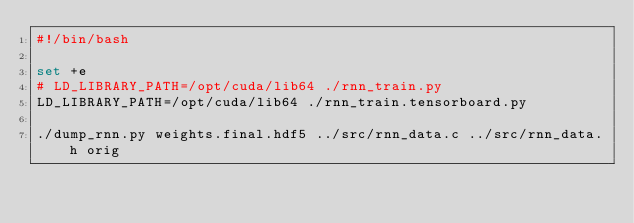<code> <loc_0><loc_0><loc_500><loc_500><_Bash_>#!/bin/bash

set +e
# LD_LIBRARY_PATH=/opt/cuda/lib64 ./rnn_train.py
LD_LIBRARY_PATH=/opt/cuda/lib64 ./rnn_train.tensorboard.py

./dump_rnn.py weights.final.hdf5 ../src/rnn_data.c ../src/rnn_data.h orig
</code> 